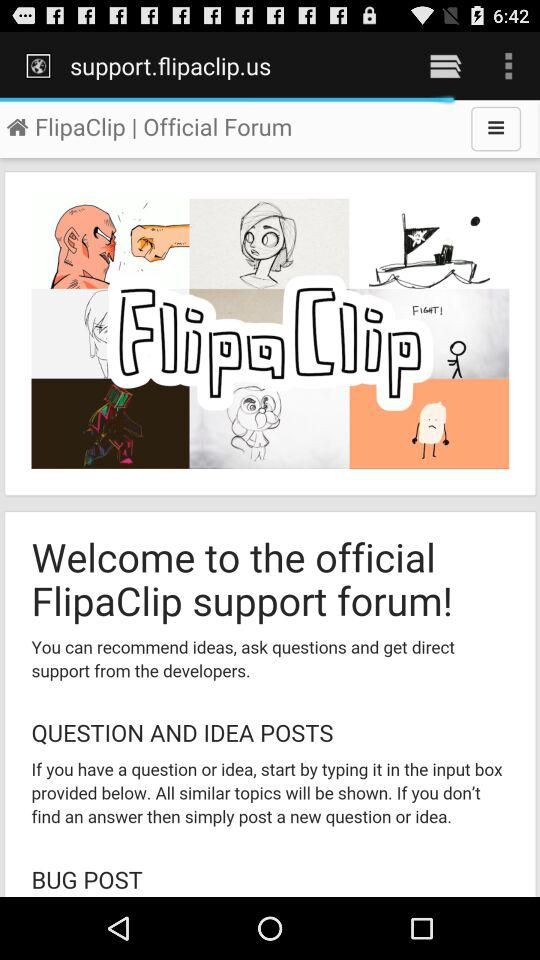What is the name of the forum? The name is FlipaClip support forum. 